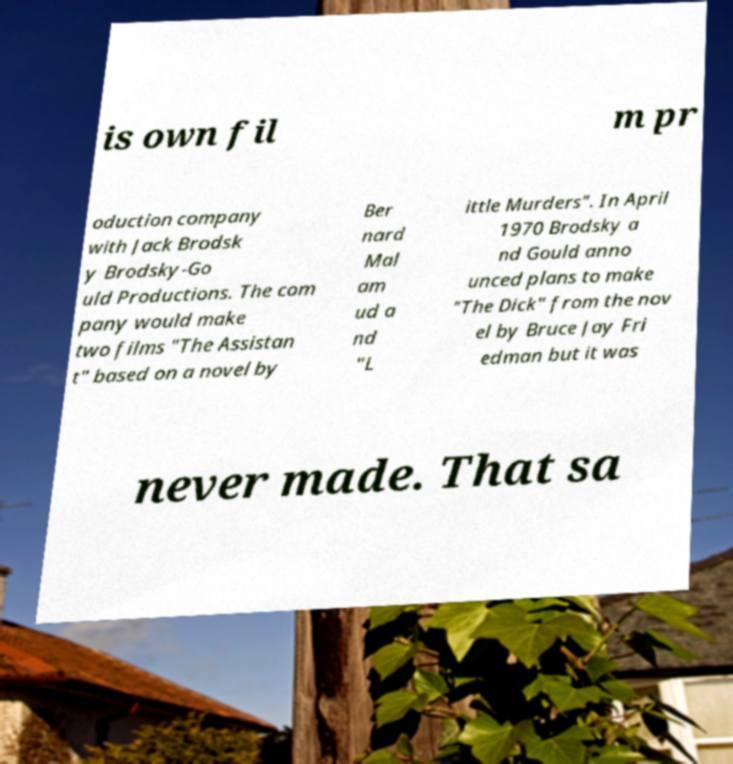Can you accurately transcribe the text from the provided image for me? is own fil m pr oduction company with Jack Brodsk y Brodsky-Go uld Productions. The com pany would make two films "The Assistan t" based on a novel by Ber nard Mal am ud a nd "L ittle Murders". In April 1970 Brodsky a nd Gould anno unced plans to make "The Dick" from the nov el by Bruce Jay Fri edman but it was never made. That sa 